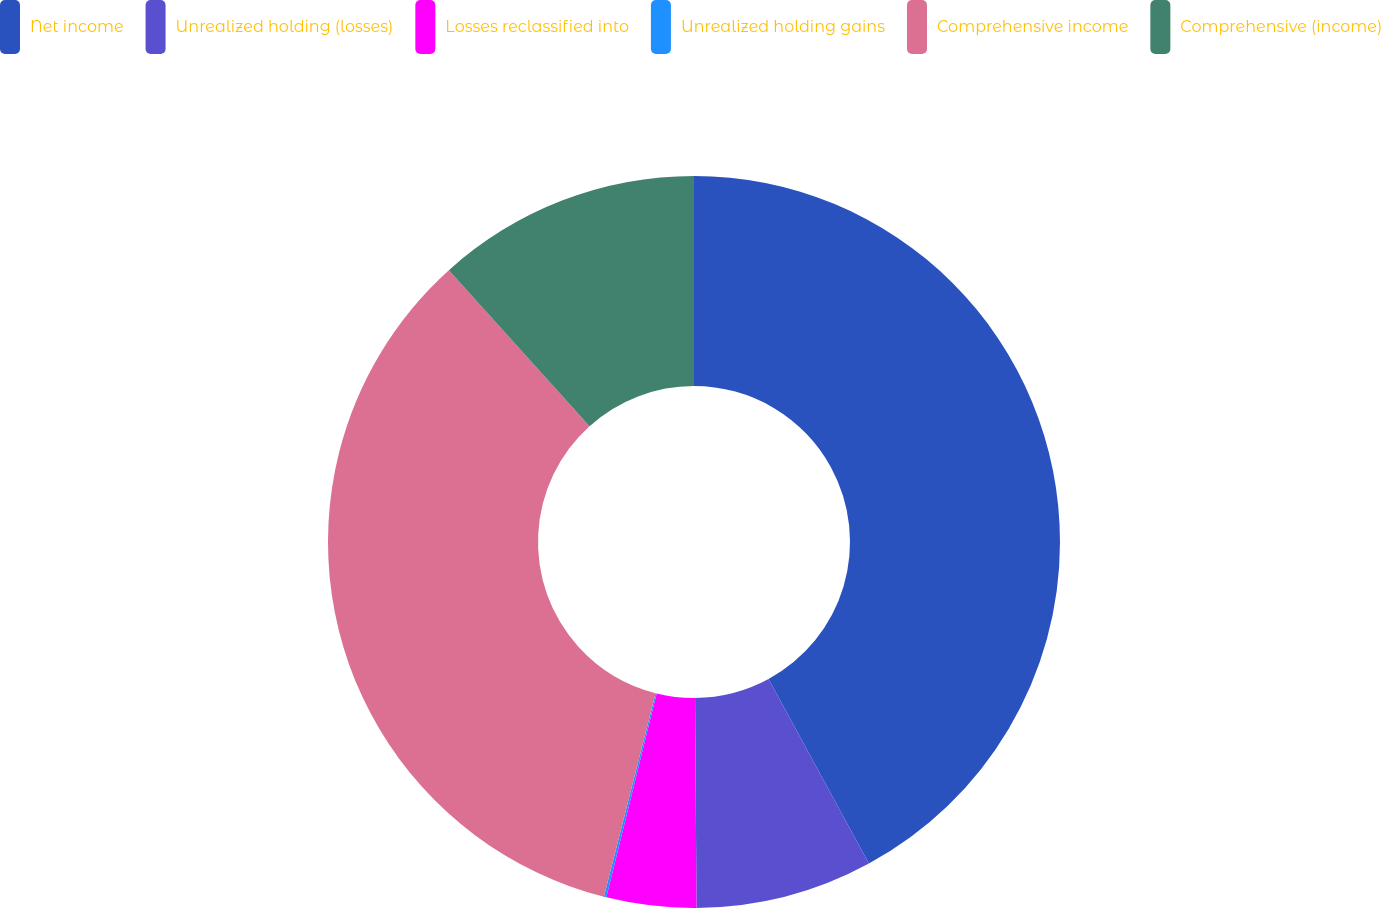<chart> <loc_0><loc_0><loc_500><loc_500><pie_chart><fcel>Net income<fcel>Unrealized holding (losses)<fcel>Losses reclassified into<fcel>Unrealized holding gains<fcel>Comprehensive income<fcel>Comprehensive (income)<nl><fcel>42.07%<fcel>7.82%<fcel>3.96%<fcel>0.11%<fcel>34.36%<fcel>11.68%<nl></chart> 